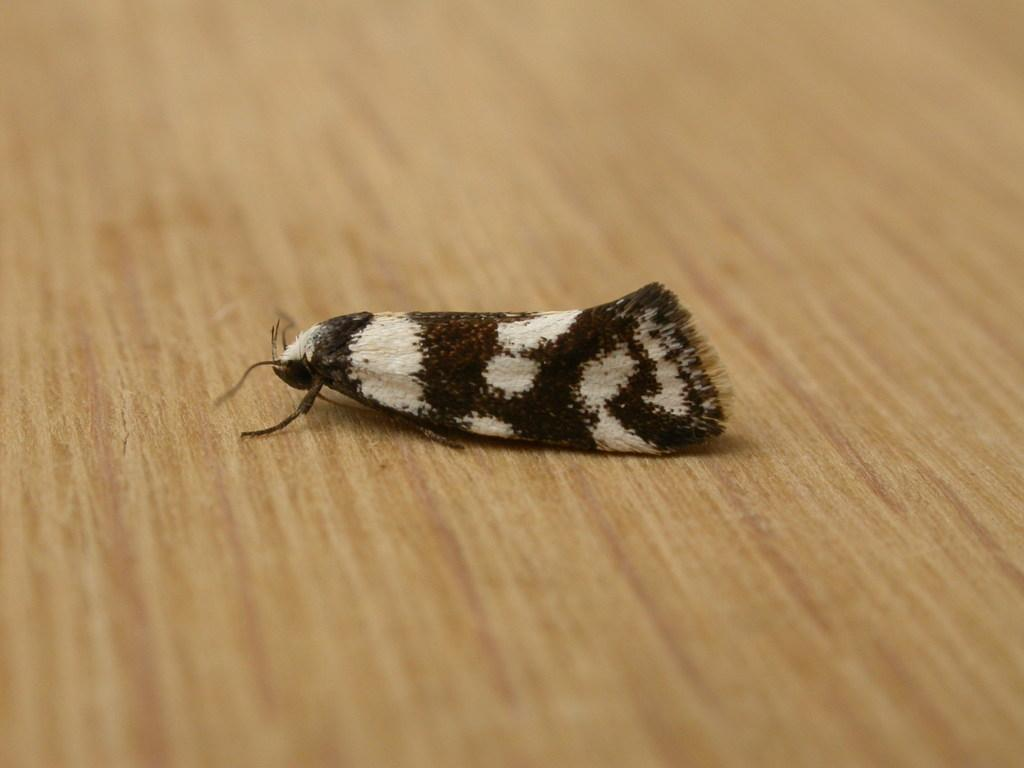What type of creature can be seen in the image? There is an insect in the image. Where is the insect located? The insect is on a wooden platform. What type of birds can be seen flying in the image? There are no birds visible in the image; it only features an insect on a wooden platform. What tool is being used by the insect to clean up leaves in the image? There is no tool, such as a rake, present in the image. 